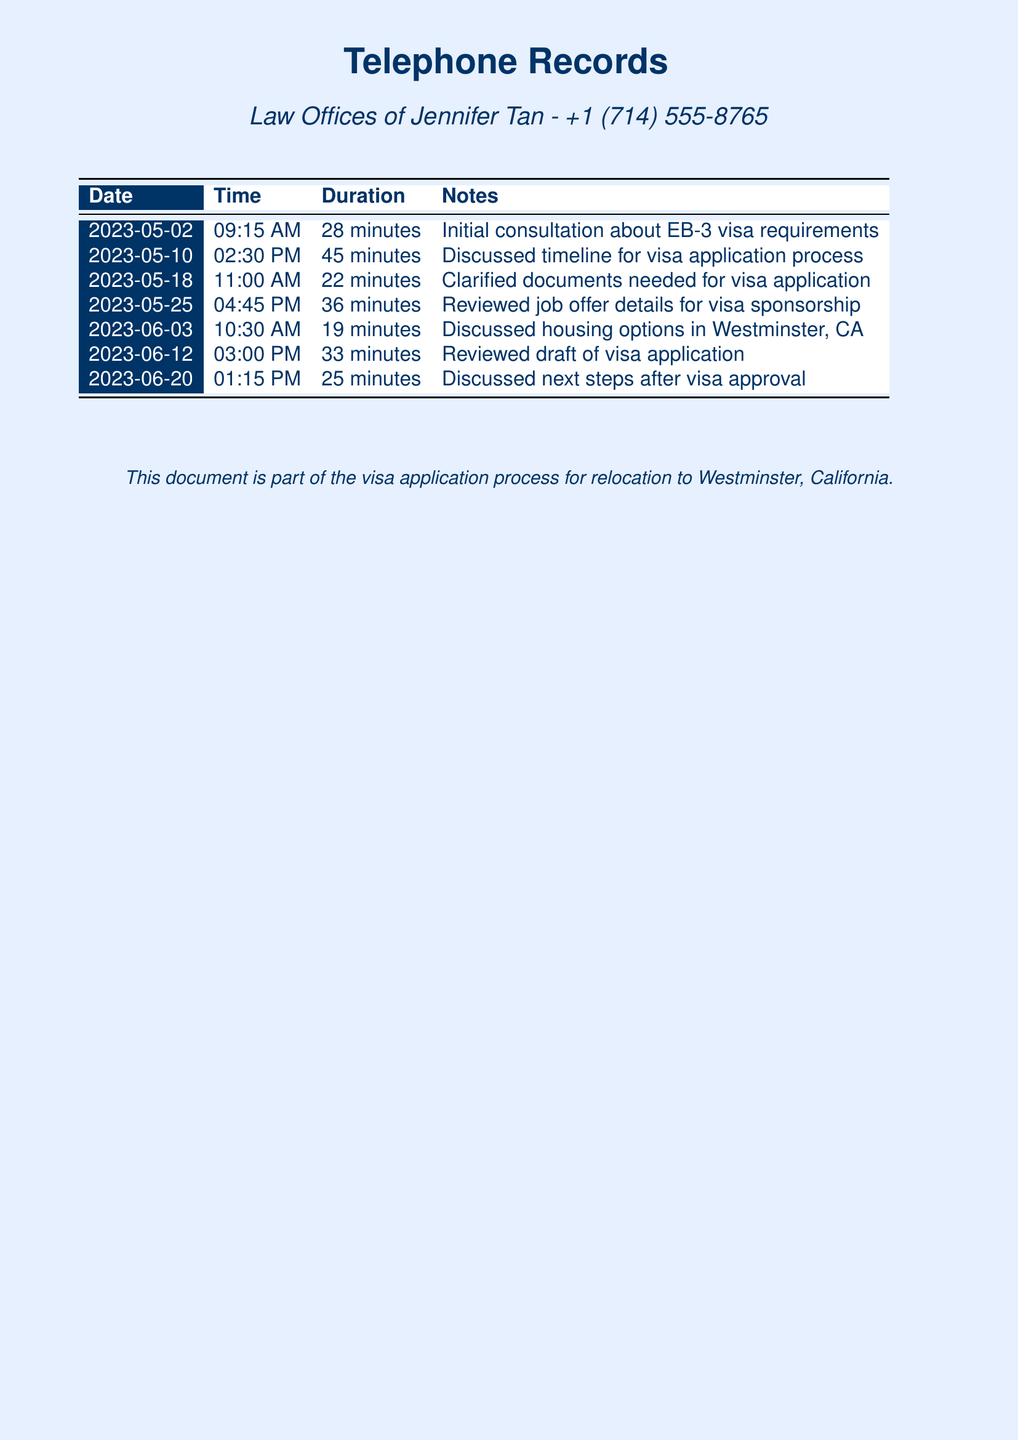What is the lawyer's name? The document mentions the law offices of Jennifer Tan, who is the immigration lawyer.
Answer: Jennifer Tan What is the phone number of the law office? The document provides the contact number for the law office, which is essential for reaching them.
Answer: +1 (714) 555-8765 How many minutes was the longest call? By reviewing the durations listed for each call, the longest call can be identified.
Answer: 45 minutes What was discussed in the call on May 18? The document states that the call on this date was to clarify documents needed for the visa application.
Answer: Clarified documents needed for visa application On which date was the initial consultation held? The date of the first call listed in the records specifically states when the initial consultation occurred.
Answer: 2023-05-02 What is the main purpose of these telephone records? The document indicates that these records are part of a process related to relocating and visa application.
Answer: Visa application process How many calls were made in total? Counting all the entries in the table reveals the total number of calls documented.
Answer: 7 calls What was the topic of discussion on June 3? The document outlines that housing options were discussed during the call on this date.
Answer: Housing options in Westminster, CA What was the duration of the call on June 12? The table specifies the duration of each call, stating that this particular call lasted a certain period.
Answer: 33 minutes 